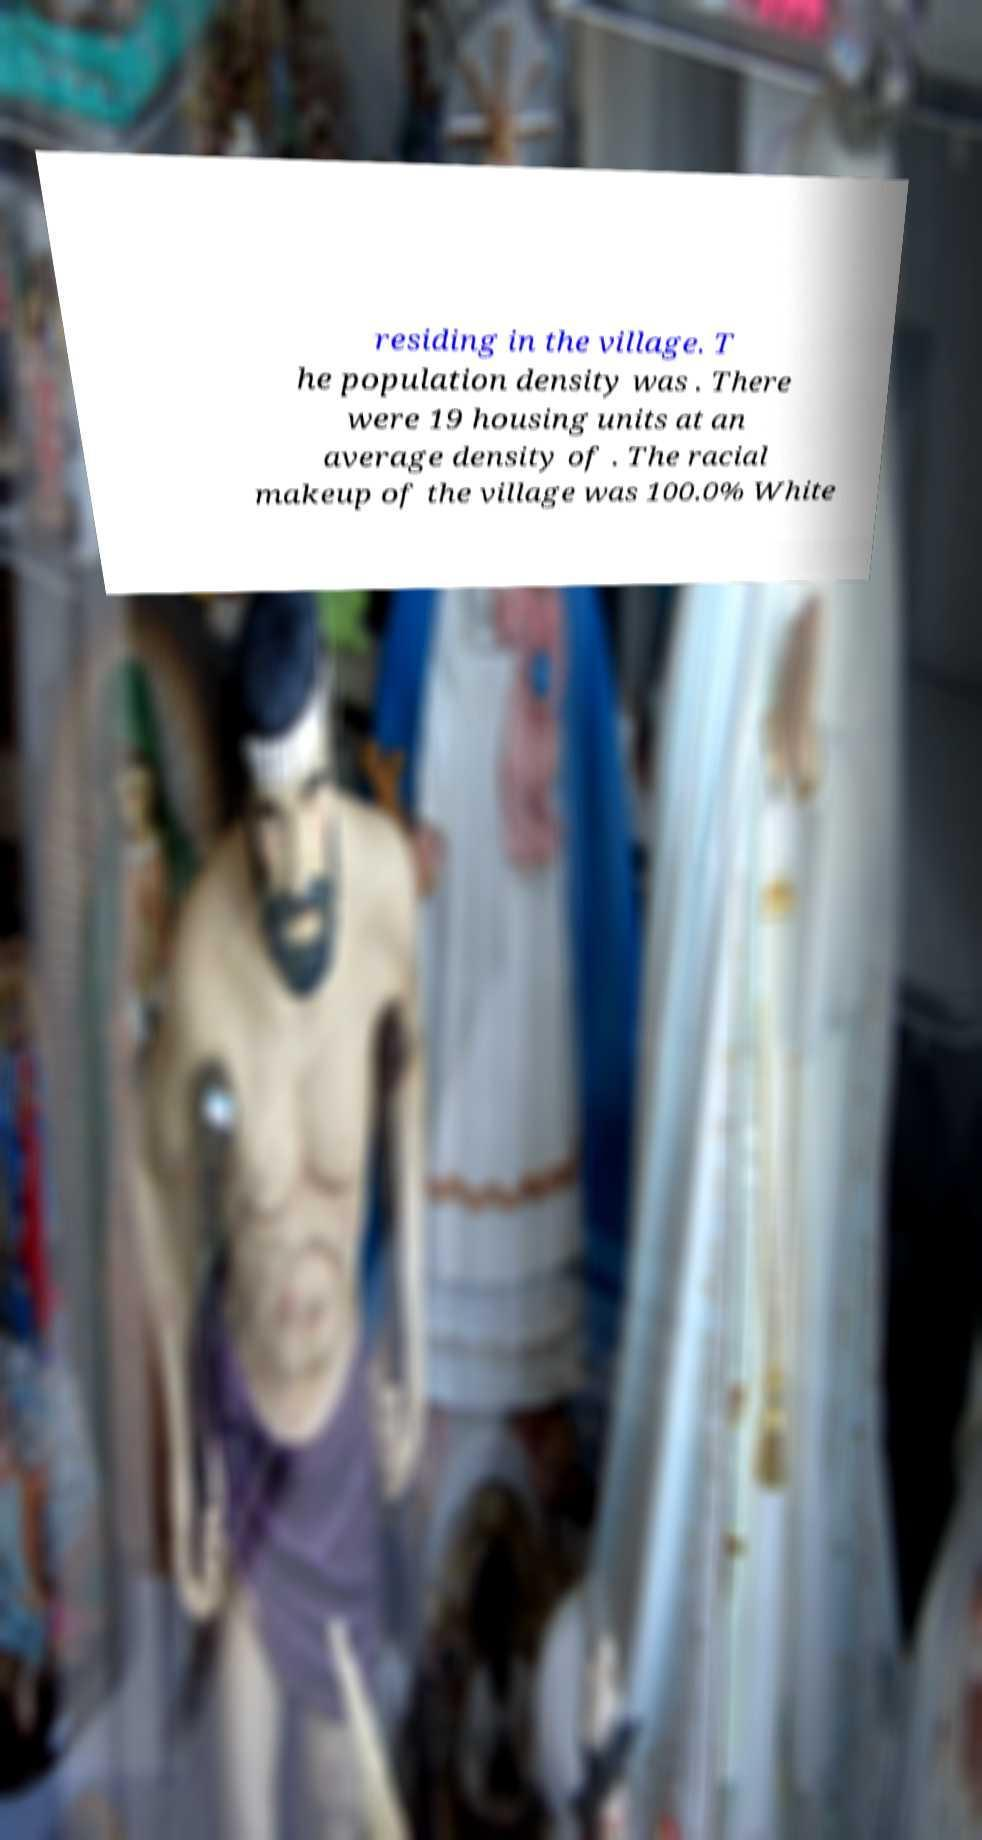For documentation purposes, I need the text within this image transcribed. Could you provide that? residing in the village. T he population density was . There were 19 housing units at an average density of . The racial makeup of the village was 100.0% White 